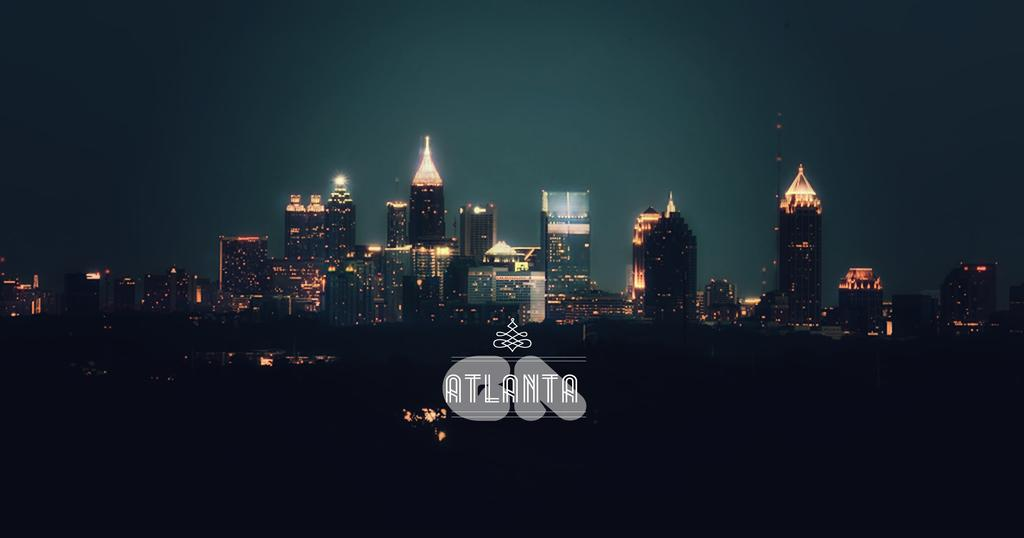<image>
Create a compact narrative representing the image presented. The skyline of Atlanta is lit up at night. 